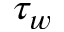Convert formula to latex. <formula><loc_0><loc_0><loc_500><loc_500>\tau _ { w }</formula> 